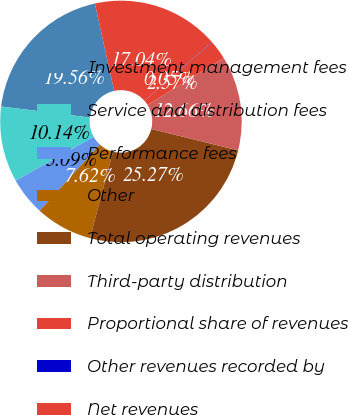Convert chart. <chart><loc_0><loc_0><loc_500><loc_500><pie_chart><fcel>Investment management fees<fcel>Service and distribution fees<fcel>Performance fees<fcel>Other<fcel>Total operating revenues<fcel>Third-party distribution<fcel>Proportional share of revenues<fcel>Other revenues recorded by<fcel>Net revenues<nl><fcel>19.56%<fcel>10.14%<fcel>5.09%<fcel>7.62%<fcel>25.27%<fcel>12.66%<fcel>2.57%<fcel>0.05%<fcel>17.04%<nl></chart> 